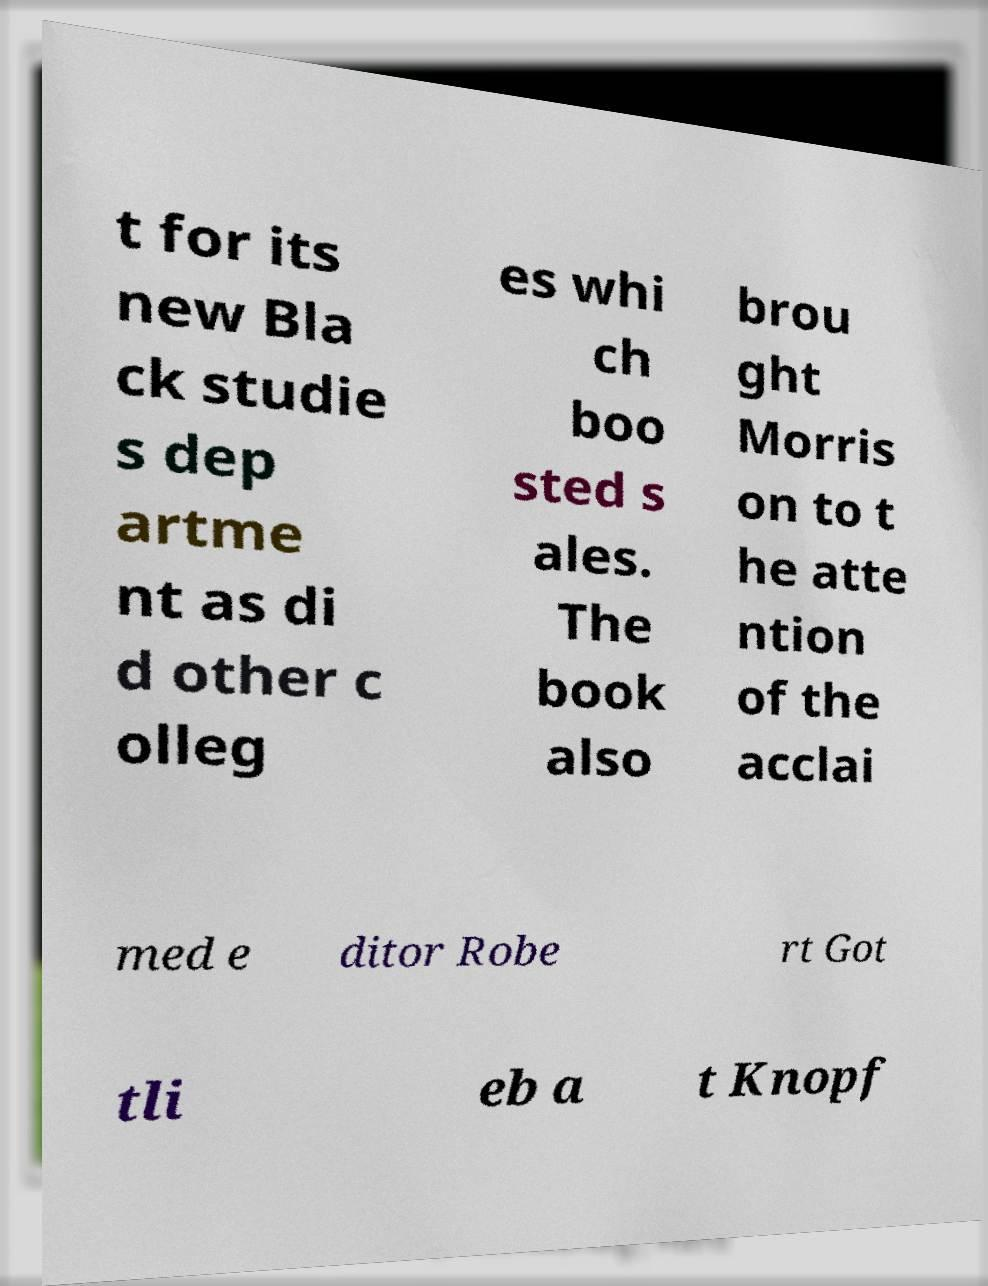Can you read and provide the text displayed in the image?This photo seems to have some interesting text. Can you extract and type it out for me? t for its new Bla ck studie s dep artme nt as di d other c olleg es whi ch boo sted s ales. The book also brou ght Morris on to t he atte ntion of the acclai med e ditor Robe rt Got tli eb a t Knopf 